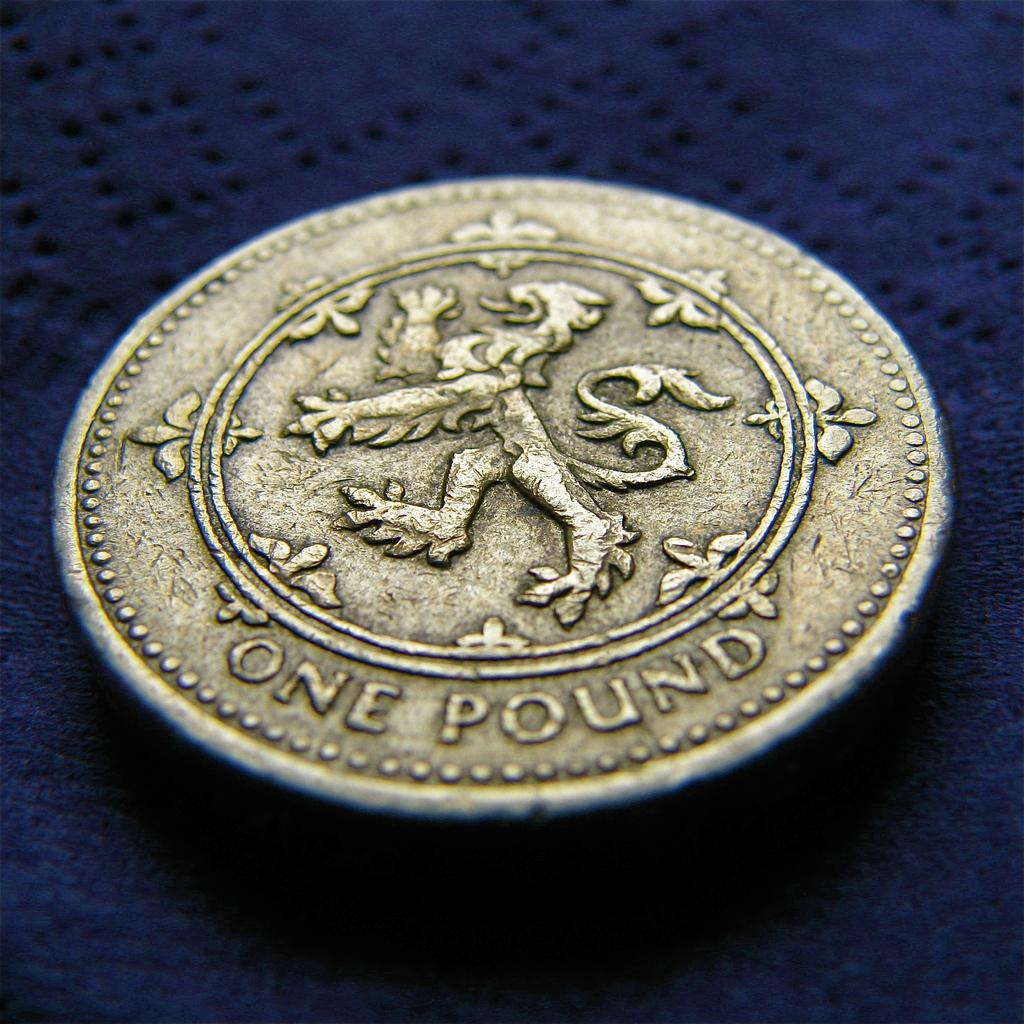<image>
Write a terse but informative summary of the picture. A one pound piece of currency on a blue background 